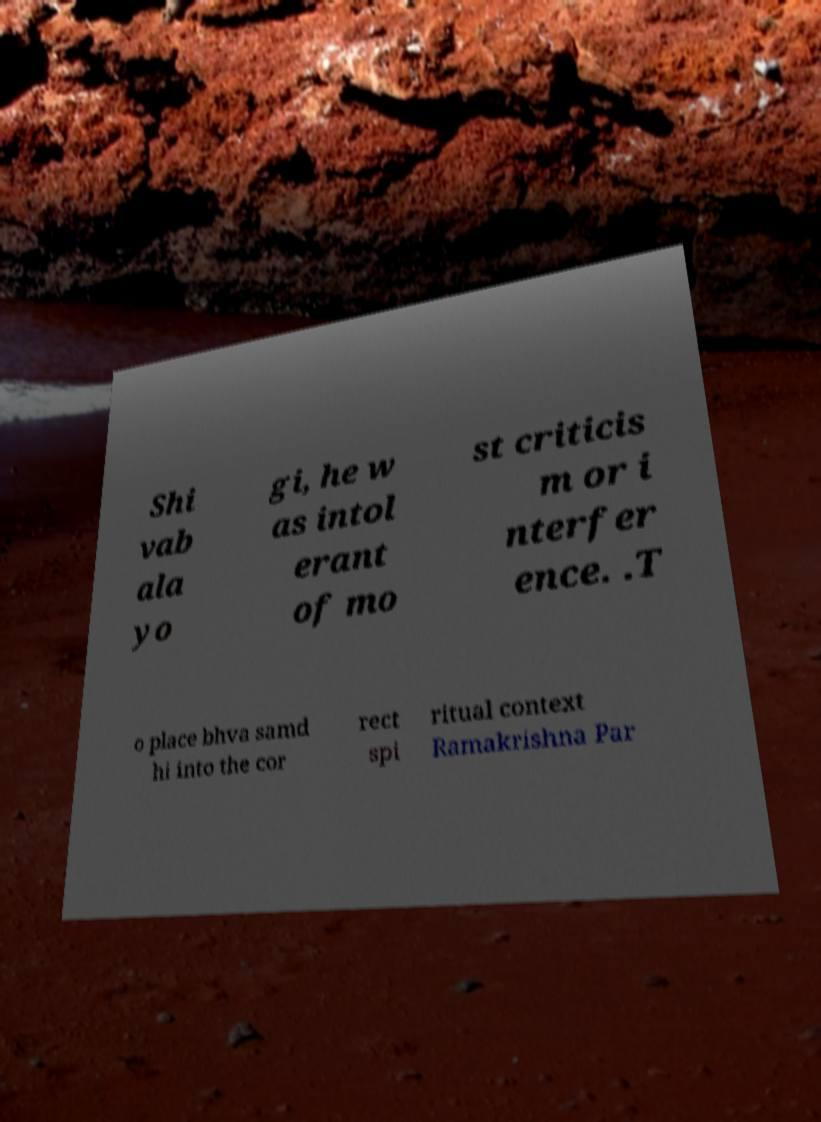What messages or text are displayed in this image? I need them in a readable, typed format. Shi vab ala yo gi, he w as intol erant of mo st criticis m or i nterfer ence. .T o place bhva samd hi into the cor rect spi ritual context Ramakrishna Par 